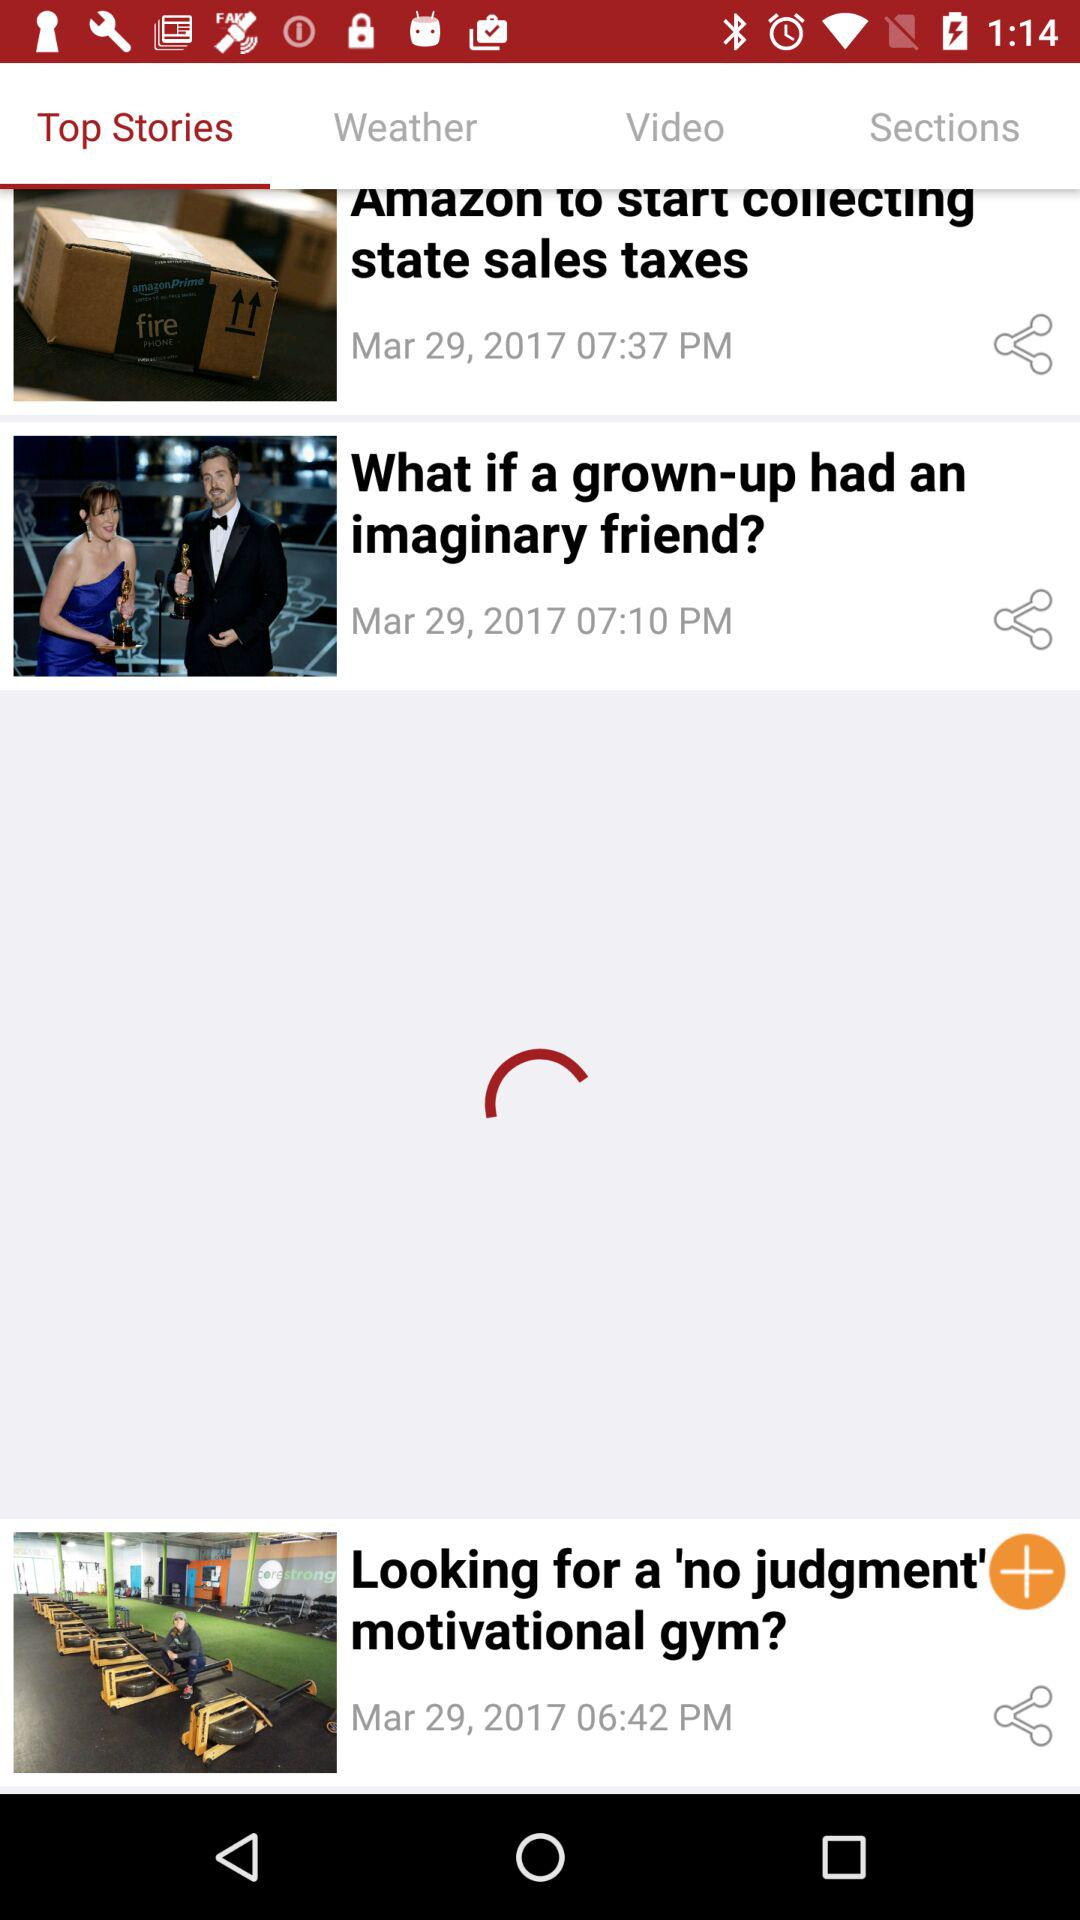On what date was "Amazon to start collecting state sales taxes" posted? "Amazon to start collecting state sales taxes" was posted on March 29th, 2017. 